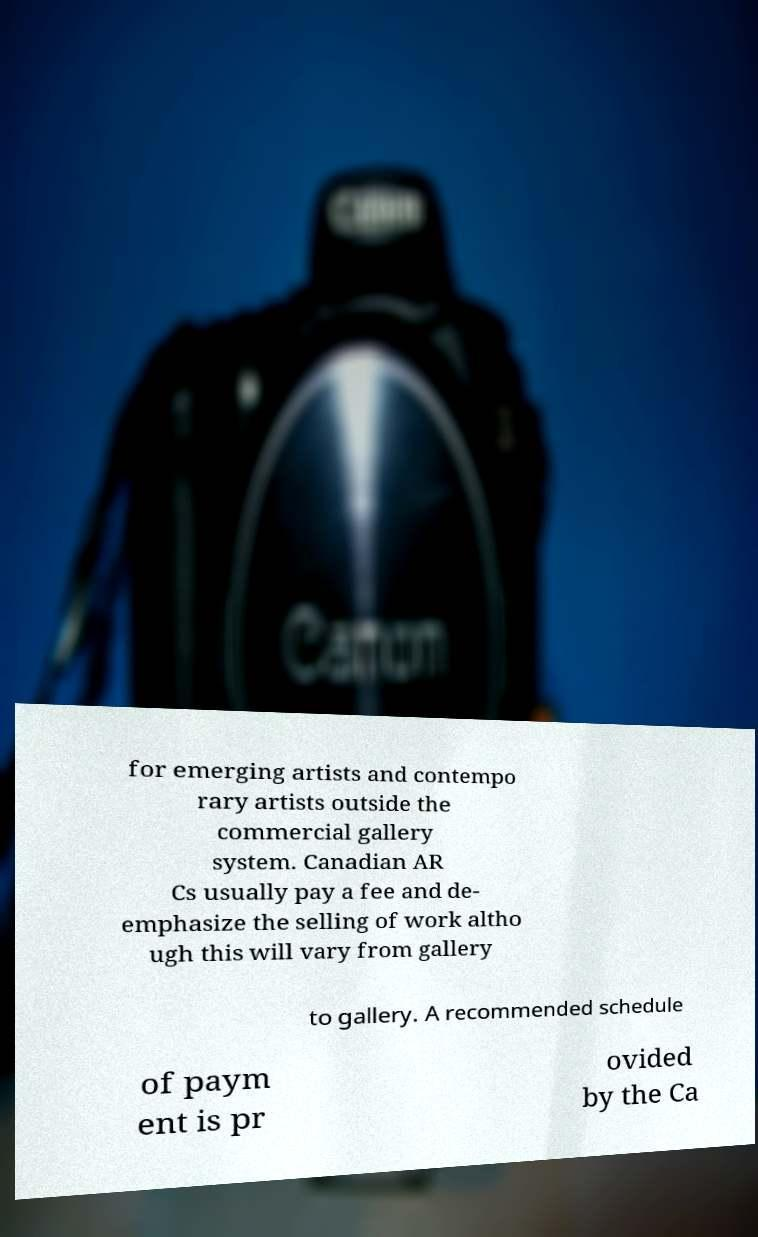Can you read and provide the text displayed in the image?This photo seems to have some interesting text. Can you extract and type it out for me? for emerging artists and contempo rary artists outside the commercial gallery system. Canadian AR Cs usually pay a fee and de- emphasize the selling of work altho ugh this will vary from gallery to gallery. A recommended schedule of paym ent is pr ovided by the Ca 